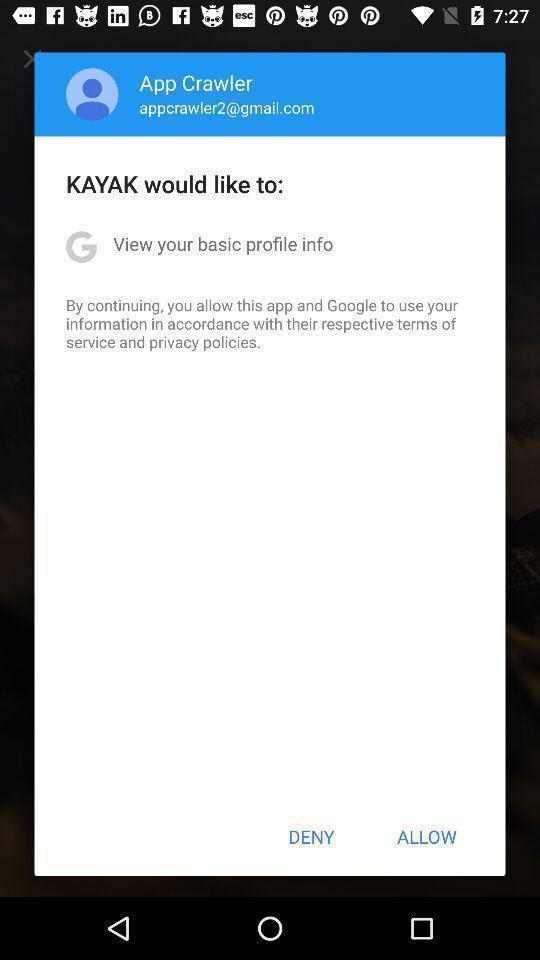Describe the visual elements of this screenshot. Pop up of profile to give the permission for further. 